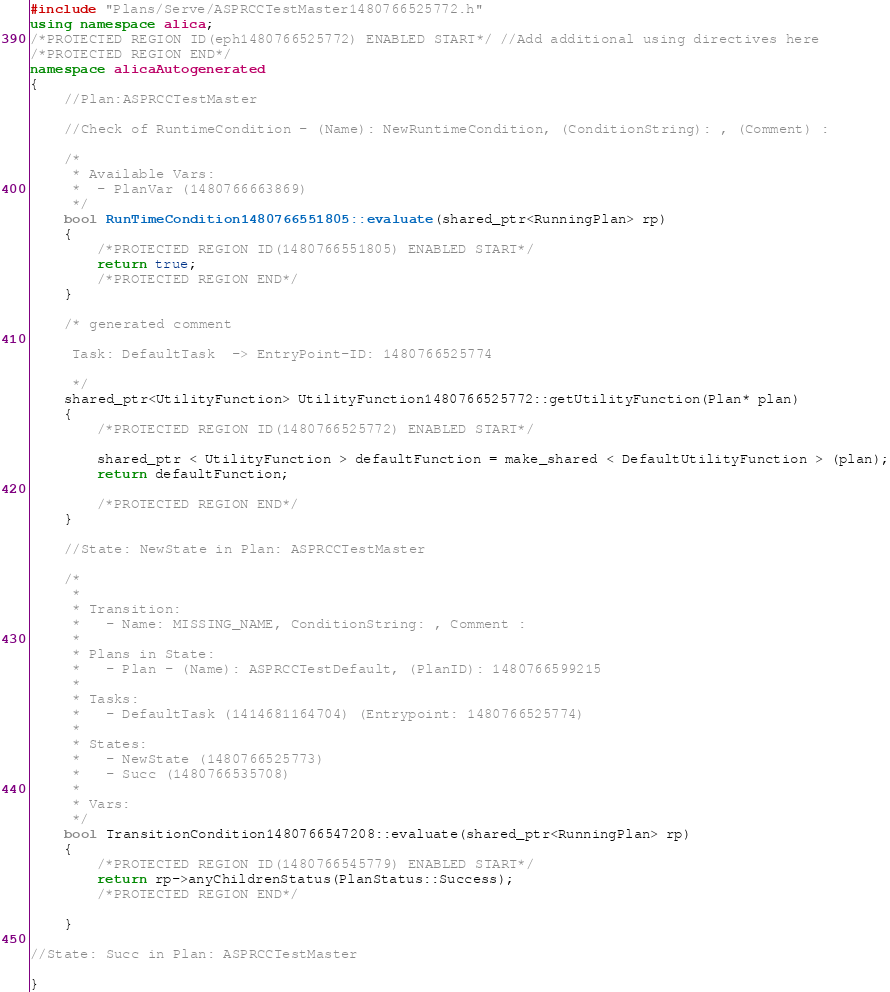<code> <loc_0><loc_0><loc_500><loc_500><_C++_>#include "Plans/Serve/ASPRCCTestMaster1480766525772.h"
using namespace alica;
/*PROTECTED REGION ID(eph1480766525772) ENABLED START*/ //Add additional using directives here
/*PROTECTED REGION END*/
namespace alicaAutogenerated
{
    //Plan:ASPRCCTestMaster

    //Check of RuntimeCondition - (Name): NewRuntimeCondition, (ConditionString): , (Comment) :  

    /* 
     * Available Vars:
     *	- PlanVar (1480766663869)
     */
    bool RunTimeCondition1480766551805::evaluate(shared_ptr<RunningPlan> rp)
    {
        /*PROTECTED REGION ID(1480766551805) ENABLED START*/
        return true;
        /*PROTECTED REGION END*/
    }

    /* generated comment
     
     Task: DefaultTask  -> EntryPoint-ID: 1480766525774

     */
    shared_ptr<UtilityFunction> UtilityFunction1480766525772::getUtilityFunction(Plan* plan)
    {
        /*PROTECTED REGION ID(1480766525772) ENABLED START*/

        shared_ptr < UtilityFunction > defaultFunction = make_shared < DefaultUtilityFunction > (plan);
        return defaultFunction;

        /*PROTECTED REGION END*/
    }

    //State: NewState in Plan: ASPRCCTestMaster

    /*
     *		
     * Transition:
     *   - Name: MISSING_NAME, ConditionString: , Comment :  
     *
     * Plans in State: 				
     *   - Plan - (Name): ASPRCCTestDefault, (PlanID): 1480766599215 
     *
     * Tasks: 
     *   - DefaultTask (1414681164704) (Entrypoint: 1480766525774)
     *
     * States:
     *   - NewState (1480766525773)
     *   - Succ (1480766535708)
     *
     * Vars:
     */
    bool TransitionCondition1480766547208::evaluate(shared_ptr<RunningPlan> rp)
    {
        /*PROTECTED REGION ID(1480766545779) ENABLED START*/
        return rp->anyChildrenStatus(PlanStatus::Success);
        /*PROTECTED REGION END*/

    }

//State: Succ in Plan: ASPRCCTestMaster

}
</code> 